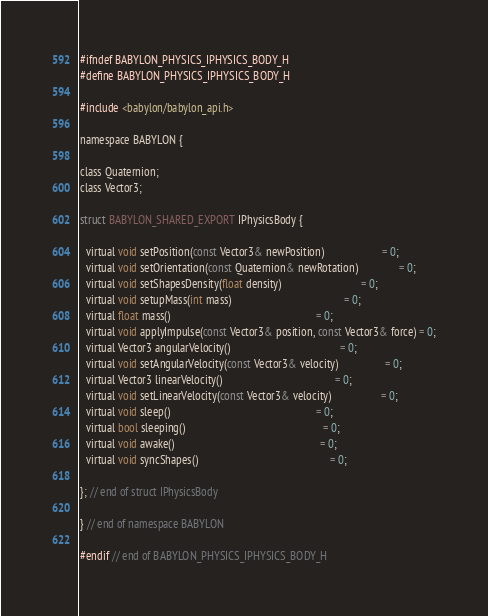<code> <loc_0><loc_0><loc_500><loc_500><_C_>#ifndef BABYLON_PHYSICS_IPHYSICS_BODY_H
#define BABYLON_PHYSICS_IPHYSICS_BODY_H

#include <babylon/babylon_api.h>

namespace BABYLON {

class Quaternion;
class Vector3;

struct BABYLON_SHARED_EXPORT IPhysicsBody {

  virtual void setPosition(const Vector3& newPosition)                     = 0;
  virtual void setOrientation(const Quaternion& newRotation)               = 0;
  virtual void setShapesDensity(float density)                             = 0;
  virtual void setupMass(int mass)                                         = 0;
  virtual float mass()                                                     = 0;
  virtual void applyImpulse(const Vector3& position, const Vector3& force) = 0;
  virtual Vector3 angularVelocity()                                        = 0;
  virtual void setAngularVelocity(const Vector3& velocity)                 = 0;
  virtual Vector3 linearVelocity()                                         = 0;
  virtual void setLinearVelocity(const Vector3& velocity)                  = 0;
  virtual void sleep()                                                     = 0;
  virtual bool sleeping()                                                  = 0;
  virtual void awake()                                                     = 0;
  virtual void syncShapes()                                                = 0;

}; // end of struct IPhysicsBody

} // end of namespace BABYLON

#endif // end of BABYLON_PHYSICS_IPHYSICS_BODY_H
</code> 